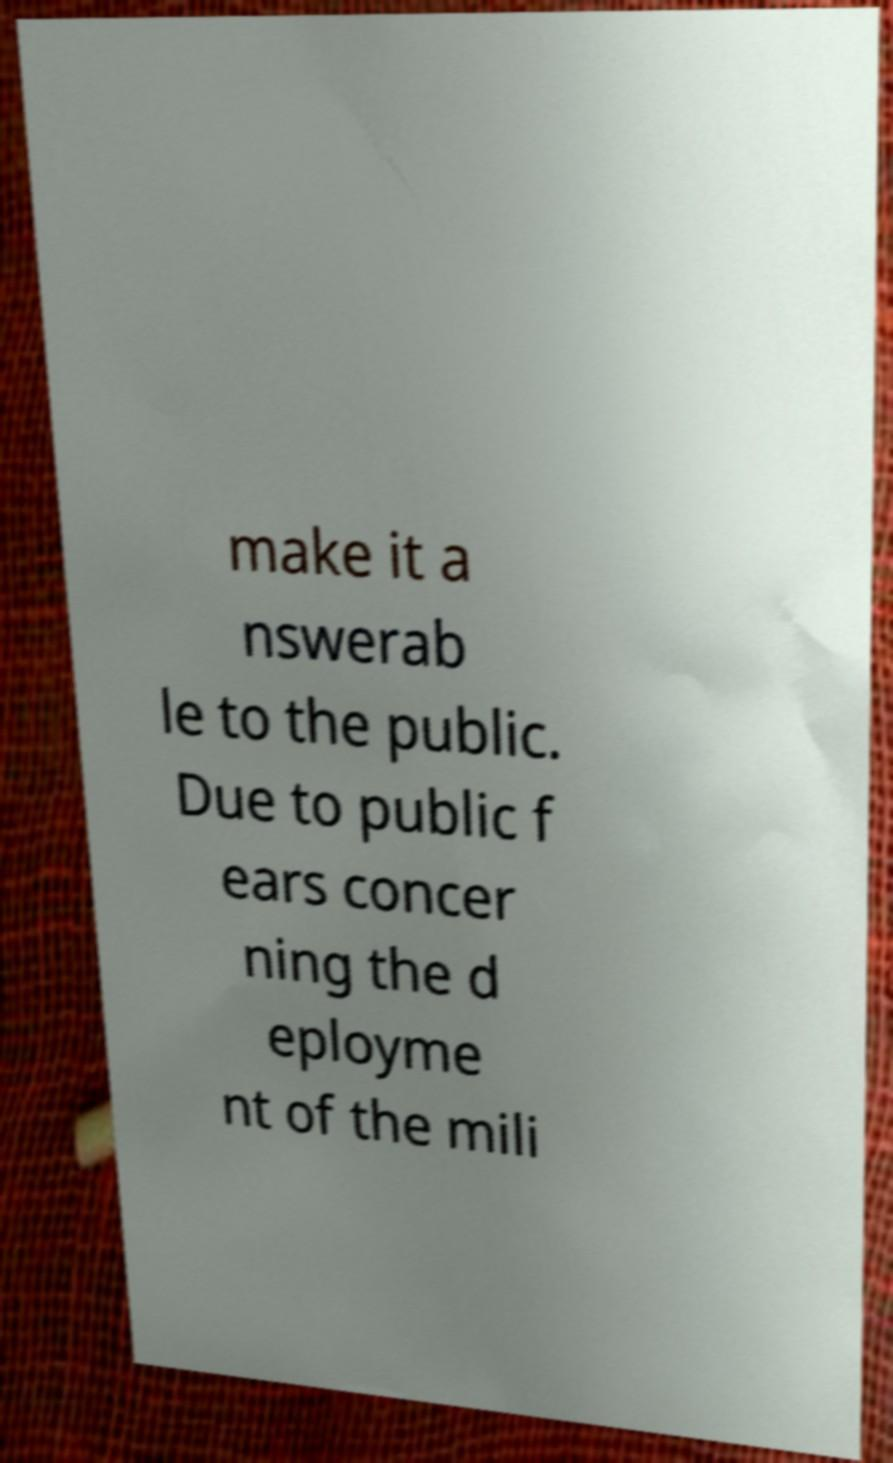Can you accurately transcribe the text from the provided image for me? make it a nswerab le to the public. Due to public f ears concer ning the d eployme nt of the mili 